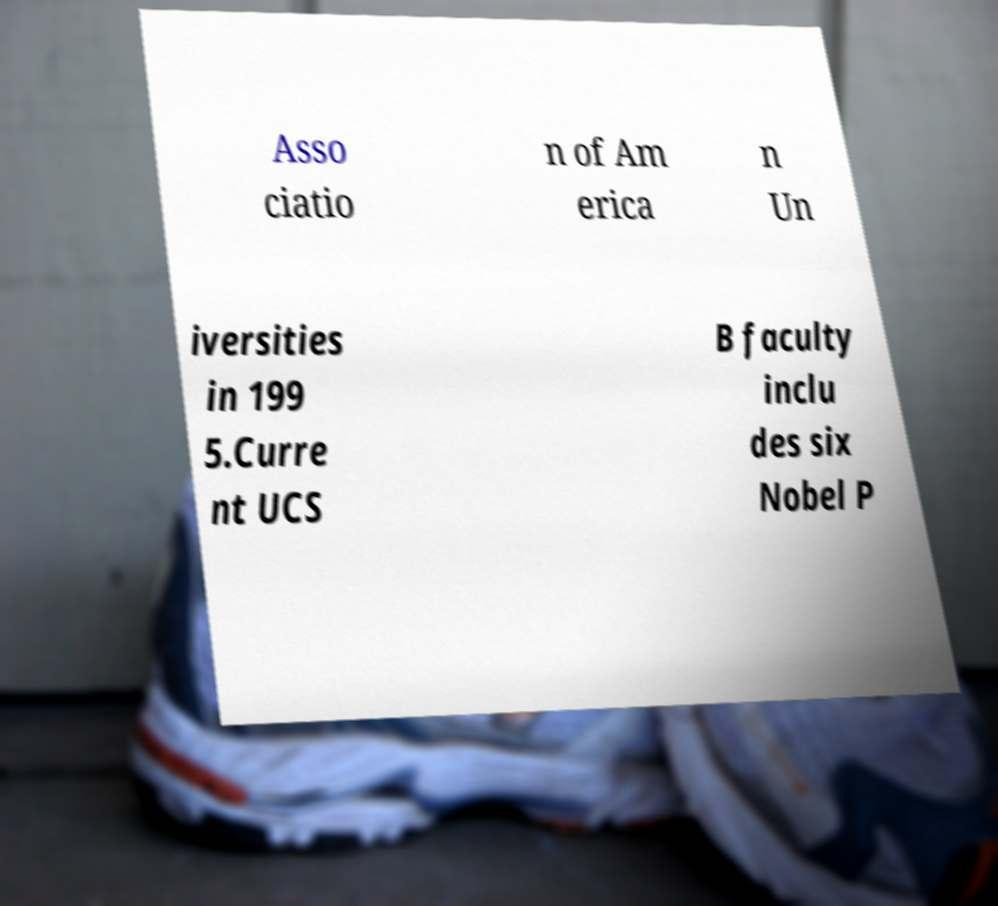I need the written content from this picture converted into text. Can you do that? Asso ciatio n of Am erica n Un iversities in 199 5.Curre nt UCS B faculty inclu des six Nobel P 